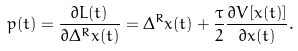<formula> <loc_0><loc_0><loc_500><loc_500>p ( t ) = \frac { \partial L ( t ) } { \partial \Delta ^ { R } x ( t ) } = \Delta ^ { R } x ( t ) + \frac { \tau } { 2 } \frac { \partial V [ x ( t ) ] } { \partial x ( t ) } .</formula> 